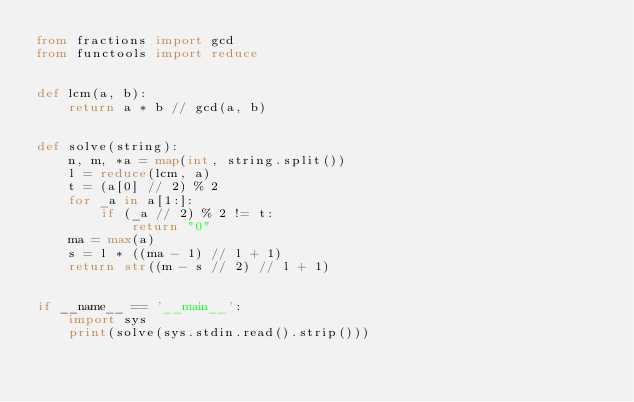<code> <loc_0><loc_0><loc_500><loc_500><_Python_>from fractions import gcd
from functools import reduce


def lcm(a, b):
    return a * b // gcd(a, b)


def solve(string):
    n, m, *a = map(int, string.split())
    l = reduce(lcm, a)
    t = (a[0] // 2) % 2
    for _a in a[1:]:
        if (_a // 2) % 2 != t:
            return "0"
    ma = max(a)
    s = l * ((ma - 1) // l + 1)
    return str((m - s // 2) // l + 1)


if __name__ == '__main__':
    import sys
    print(solve(sys.stdin.read().strip()))
</code> 